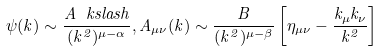<formula> <loc_0><loc_0><loc_500><loc_500>\psi ( k ) \sim \frac { A \ k s l a s h } { ( k ^ { 2 } ) ^ { \mu - \alpha } } , A _ { \mu \nu } ( k ) \sim \frac { B } { ( k ^ { 2 } ) ^ { \mu - \beta } } \left [ \eta _ { \mu \nu } - \frac { k _ { \mu } k _ { \nu } } { k ^ { 2 } } \right ]</formula> 